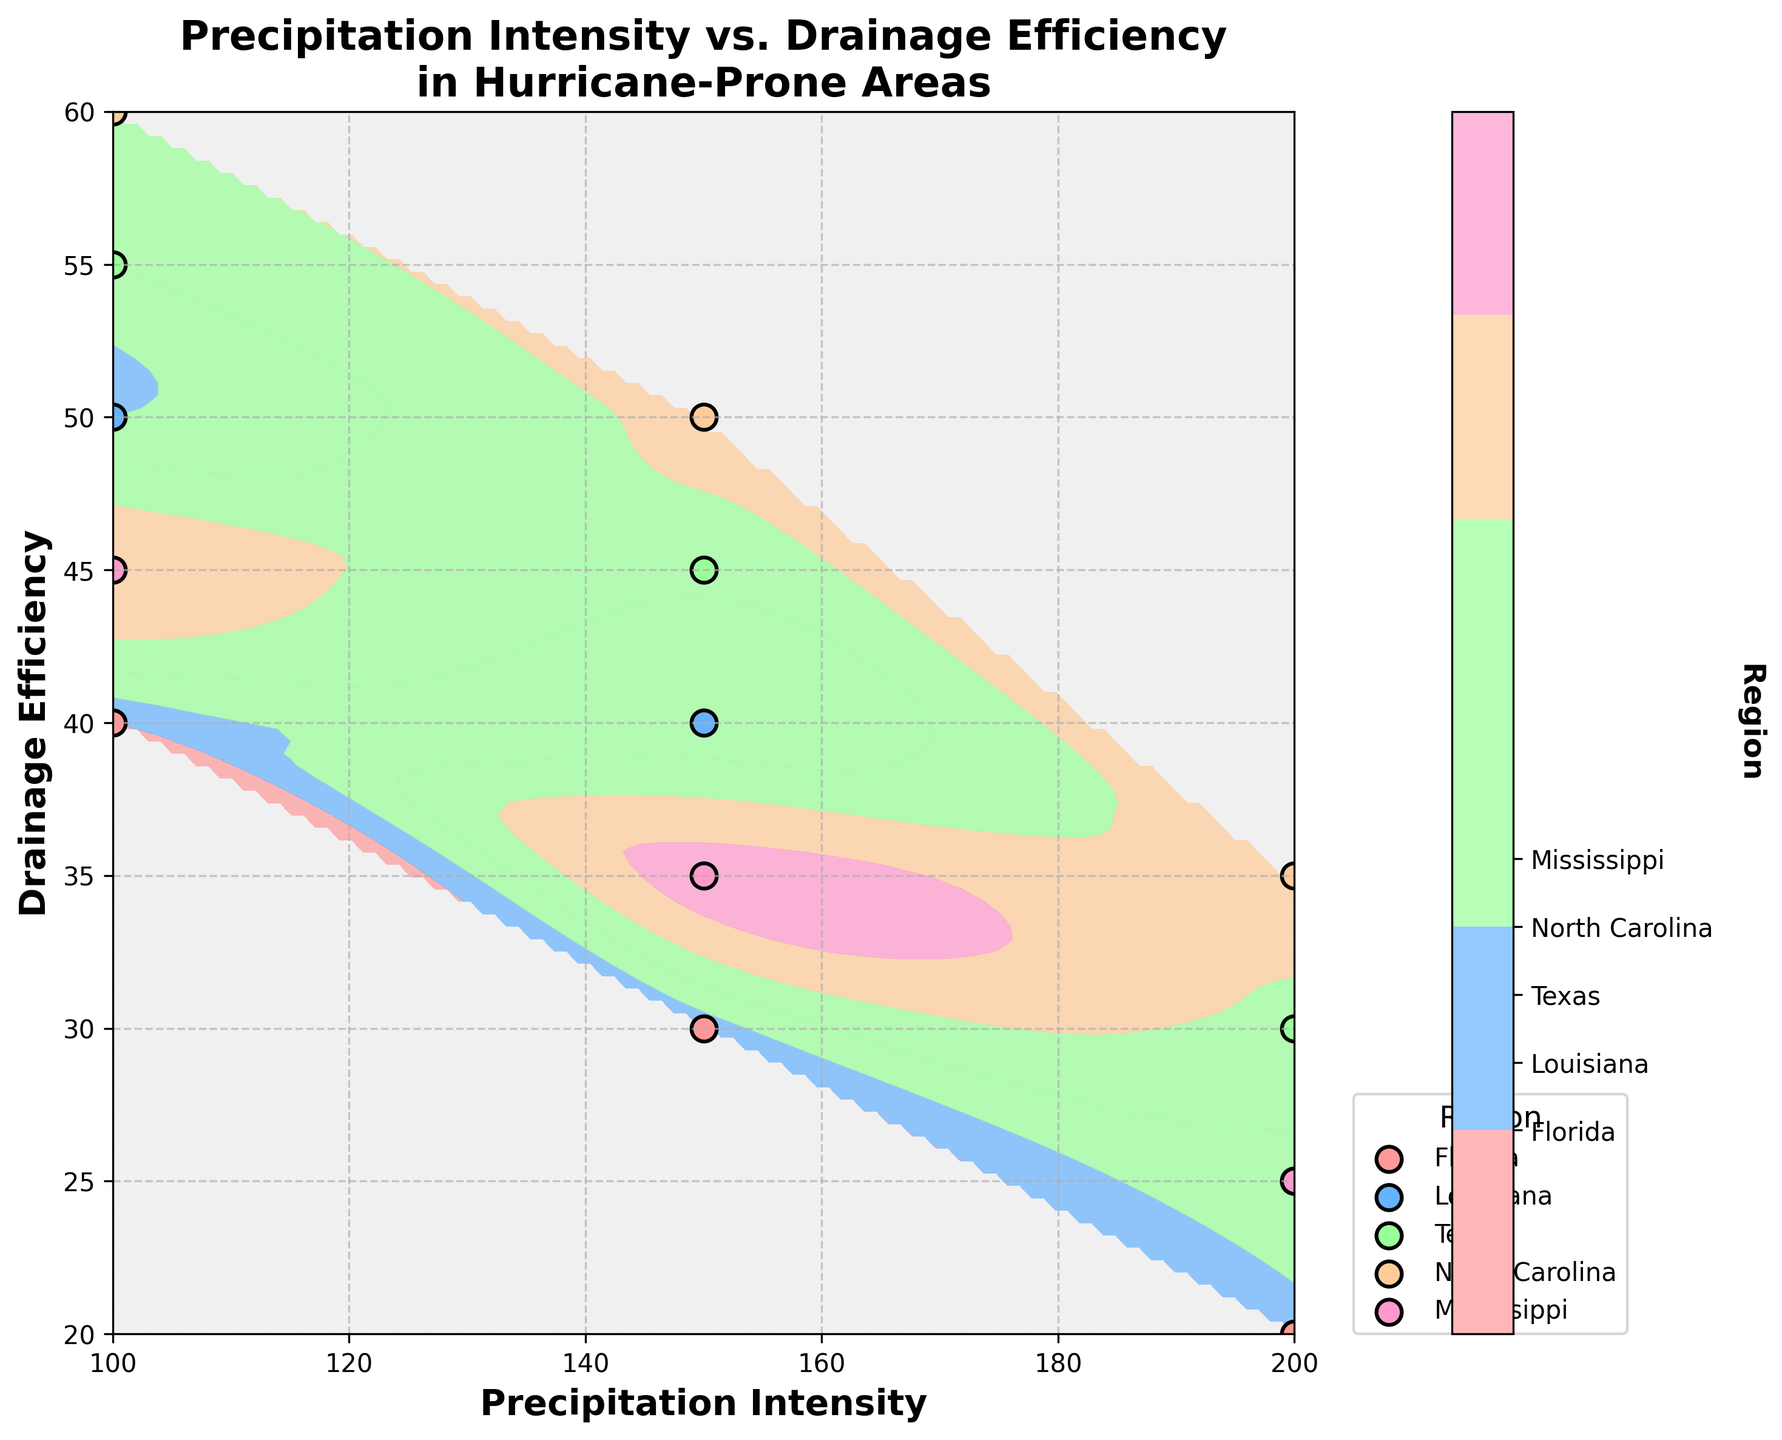What is the title of the plot? The title is written at the top center of the plot and reads "Precipitation Intensity vs. Drainage Efficiency in Hurricane-Prone Areas."
Answer: Precipitation Intensity vs. Drainage Efficiency in Hurricane-Prone Areas What does the x-axis represent? The label on the x-axis indicates that it represents "Precipitation Intensity."
Answer: Precipitation Intensity How many regions are represented in the plot? The legend shows five different colors, each labeled with a region name, and the color bar also has five ticks labeled with region names.
Answer: Five regions Which region appears to have the highest average Drainage Efficiency? By observing the scatter points, North Carolina has the highest average Drainage Efficiency because its points appear higher on the y-axis compared to other regions.
Answer: North Carolina What is the relationship between Precipitation Intensity and Drainage Efficiency for Florida? For Florida, as Precipitation Intensity increases from 100 to 200, the Drainage Efficiency decreases from 40 to 20. The relationship shows an inverse trend.
Answer: Inverse trend Which region has the most spread out data points in terms of Drainage Efficiency? Referring to the plot, North Carolina has its data points spread between Drainage Efficiency values of 35 to 60, which indicates the largest range.
Answer: North Carolina Compare the Drainage Efficiency of Louisiana and Texas at a Precipitation Intensity of 150. By looking at the points at Precipitation Intensity 150, Louisiana has a Drainage Efficiency of 40, while Texas has 45. Texas has a higher Drainage Efficiency than Louisiana for this intensity.
Answer: Texas How does the color distribution on the contour plot reflect regional data points? The darker colors in the contour plot correspond to areas where specific regions have data points. For instance, lighter areas like orange are dominant where North Carolina data points are prevalent.
Answer: Regional data points reflected by color What might be the Drainage Efficiency at a Precipitation Intensity of 175 in Louisiana as interpolated by the contour plot? Interpolating from the contour plot, it's between the points 150 (40) and 200 (25). The contour values suggest a relative interpolation gives around 32.5.
Answer: Approximately 32.5 What is the significance of the colors used in the contour plot? The colors represent different regions, which help in visualizing and differentiating the regions' data densities and distributions on the plot. They are also labeled in the color bar.
Answer: Different regions 